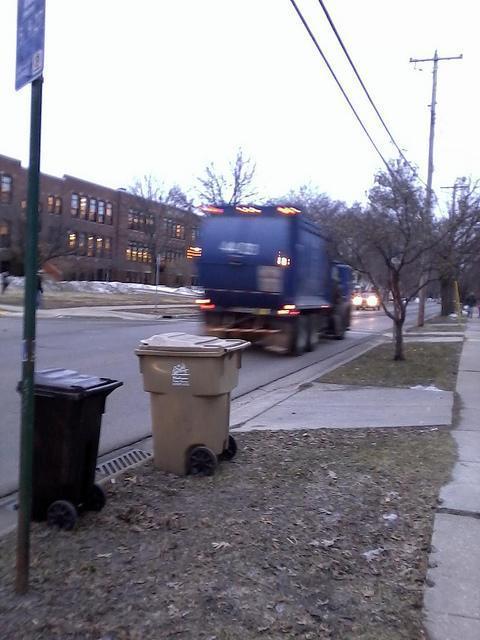How many people are there?
Give a very brief answer. 0. 